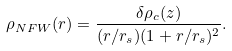Convert formula to latex. <formula><loc_0><loc_0><loc_500><loc_500>\rho _ { N F W } ( r ) = \frac { \delta \rho _ { c } ( z ) } { ( r / r _ { s } ) ( 1 + r / r _ { s } ) ^ { 2 } } .</formula> 